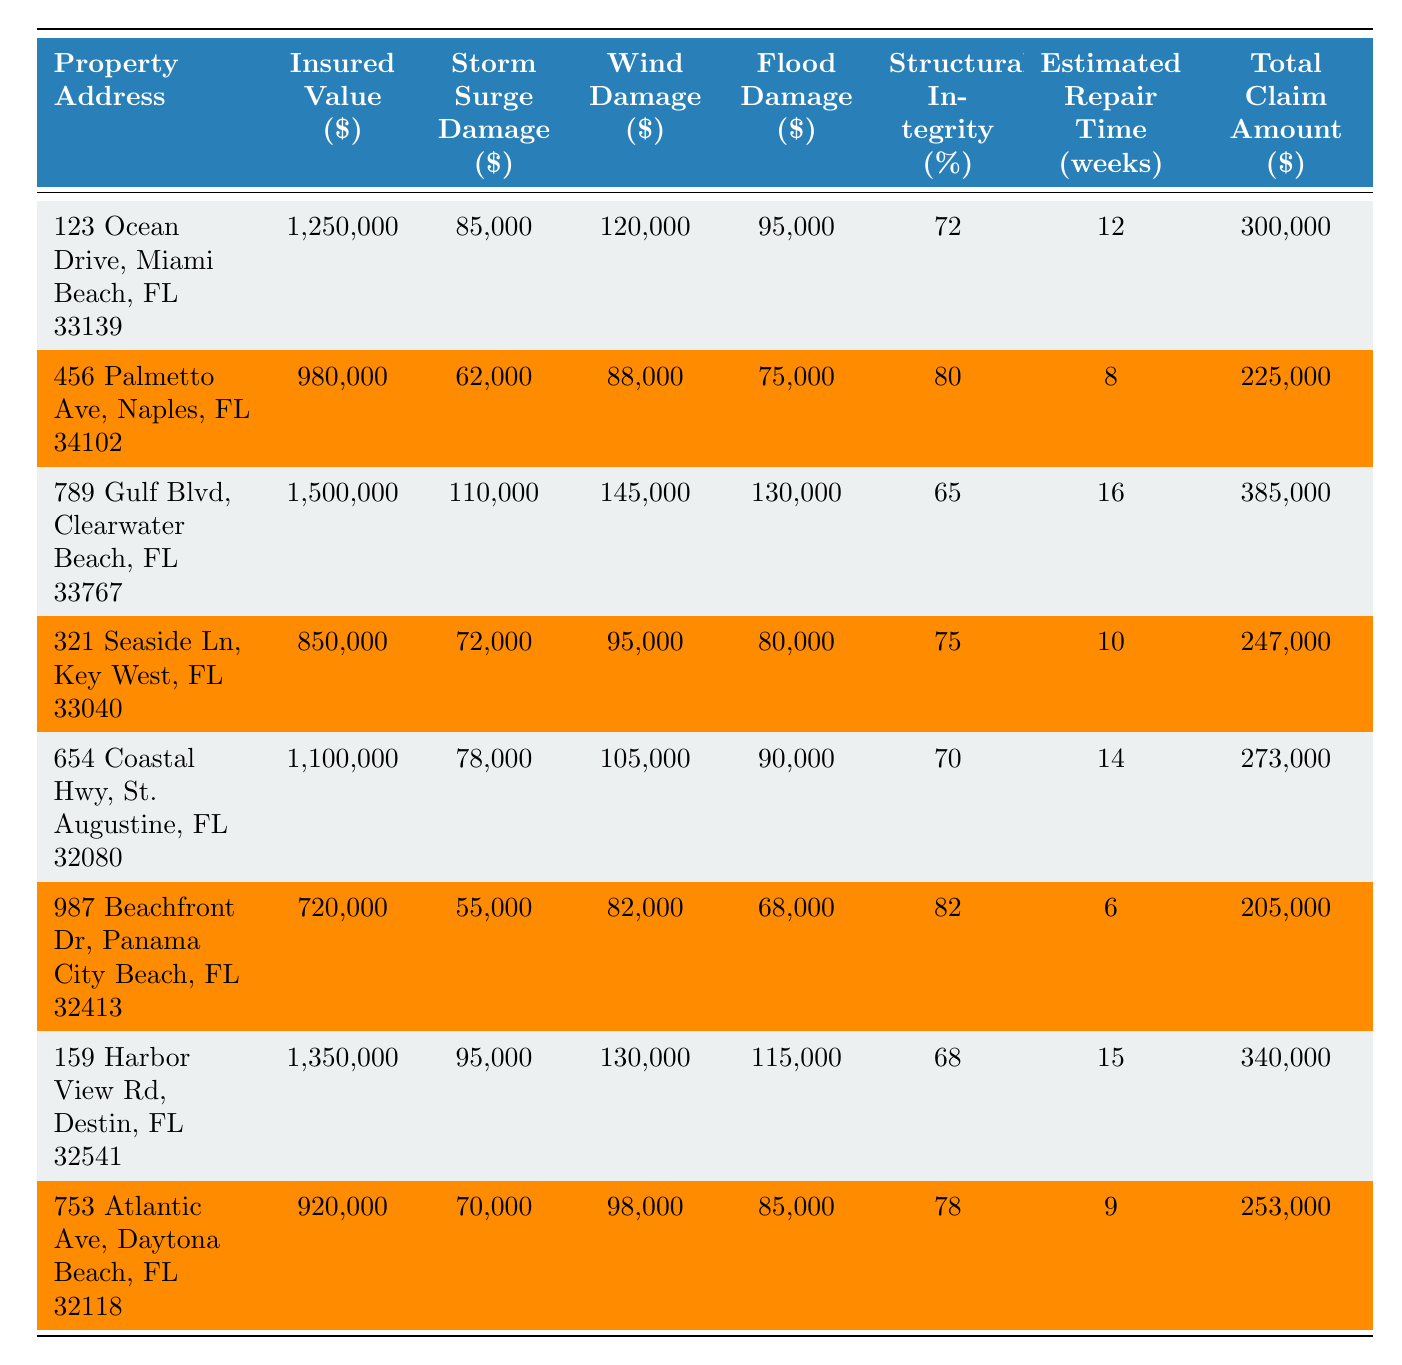What is the total claim amount for the property at 123 Ocean Drive? The table shows that the total claim amount for 123 Ocean Drive, Miami Beach, FL 33139 is listed as $300,000.
Answer: $300,000 Which property experienced the highest wind damage? The table indicates that 789 Gulf Blvd, Clearwater Beach, FL 33767 has the highest wind damage amount at $145,000.
Answer: $145,000 How much flood damage is reported for 456 Palmetto Ave? According to the table, the flood damage for 456 Palmetto Ave, Naples, FL 34102 is $75,000.
Answer: $75,000 What is the average insured value of the properties listed? The insured values are $1,250,000, $980,000, $1,500,000, $850,000, $1,100,000, $720,000, $1,350,000, and $920,000. Summing these values gives $8,770,000, and dividing by 8 properties gives an average of $1,096,250.
Answer: $1,096,250 Is there a property with a structural integrity of less than 70%? Examining the table, only 789 Gulf Blvd, Clearwater Beach, FL 33767 shows a structural integrity of 65%, which is less than 70%.
Answer: Yes What is the total damage (storm surge, wind, and flood) for the property at 654 Coastal Hwy? For 654 Coastal Hwy, St. Augustine, FL 32080, the storm surge damage is $78,000, wind damage is $105,000, and flood damage is $90,000. The total is $78,000 + $105,000 + $90,000 = $273,000.
Answer: $273,000 Which two properties have the longest estimated repair times, and what are those times? The properties with the longest repair times are 789 Gulf Blvd with 16 weeks and 159 Harbor View Rd with 15 weeks. By comparing the estimated repair times listed, these are the two longest.
Answer: 16 weeks, 15 weeks What is the difference in total claim amounts between the most and least expensive properties based on insured value? The most insured property is 789 Gulf Blvd with a total claim of $385,000, while the least insured property is 987 Beachfront Dr with a total claim of $205,000. The difference is $385,000 - $205,000 = $180,000.
Answer: $180,000 How many properties have an insured value above $1 million? By inspecting the table, the properties with an insured value above $1 million are 123 Ocean Drive, 789 Gulf Blvd, 654 Coastal Hwy, and 159 Harbor View Rd. This totals to 4 properties.
Answer: 4 